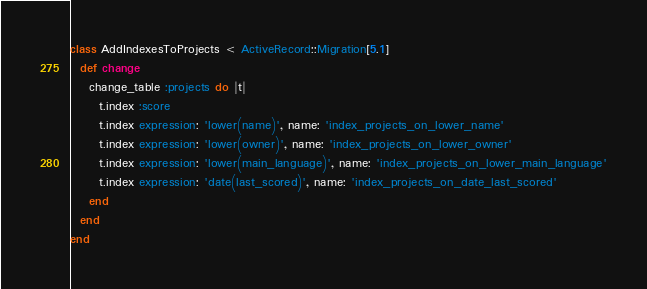Convert code to text. <code><loc_0><loc_0><loc_500><loc_500><_Ruby_>class AddIndexesToProjects < ActiveRecord::Migration[5.1]
  def change
    change_table :projects do |t|
      t.index :score
      t.index expression: 'lower(name)', name: 'index_projects_on_lower_name'
      t.index expression: 'lower(owner)', name: 'index_projects_on_lower_owner'
      t.index expression: 'lower(main_language)', name: 'index_projects_on_lower_main_language'
      t.index expression: 'date(last_scored)', name: 'index_projects_on_date_last_scored'
    end
  end
end
</code> 